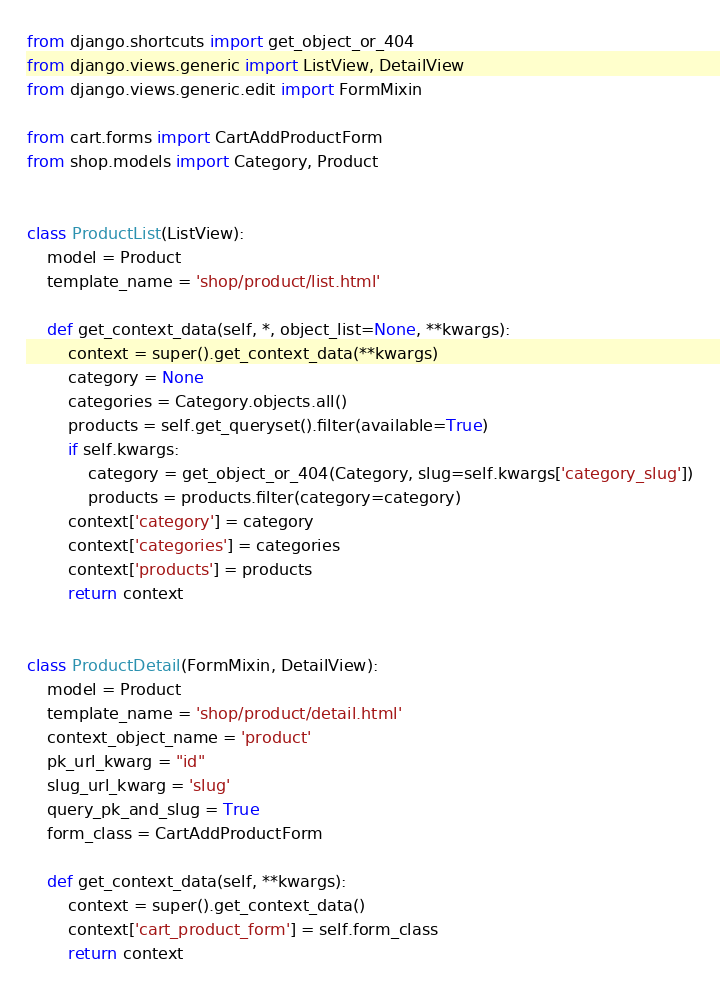Convert code to text. <code><loc_0><loc_0><loc_500><loc_500><_Python_>from django.shortcuts import get_object_or_404
from django.views.generic import ListView, DetailView
from django.views.generic.edit import FormMixin

from cart.forms import CartAddProductForm
from shop.models import Category, Product


class ProductList(ListView):
    model = Product
    template_name = 'shop/product/list.html'

    def get_context_data(self, *, object_list=None, **kwargs):
        context = super().get_context_data(**kwargs)
        category = None
        categories = Category.objects.all()
        products = self.get_queryset().filter(available=True)
        if self.kwargs:
            category = get_object_or_404(Category, slug=self.kwargs['category_slug'])
            products = products.filter(category=category)
        context['category'] = category
        context['categories'] = categories
        context['products'] = products
        return context


class ProductDetail(FormMixin, DetailView):
    model = Product
    template_name = 'shop/product/detail.html'
    context_object_name = 'product'
    pk_url_kwarg = "id"
    slug_url_kwarg = 'slug'
    query_pk_and_slug = True
    form_class = CartAddProductForm

    def get_context_data(self, **kwargs):
        context = super().get_context_data()
        context['cart_product_form'] = self.form_class
        return context


</code> 